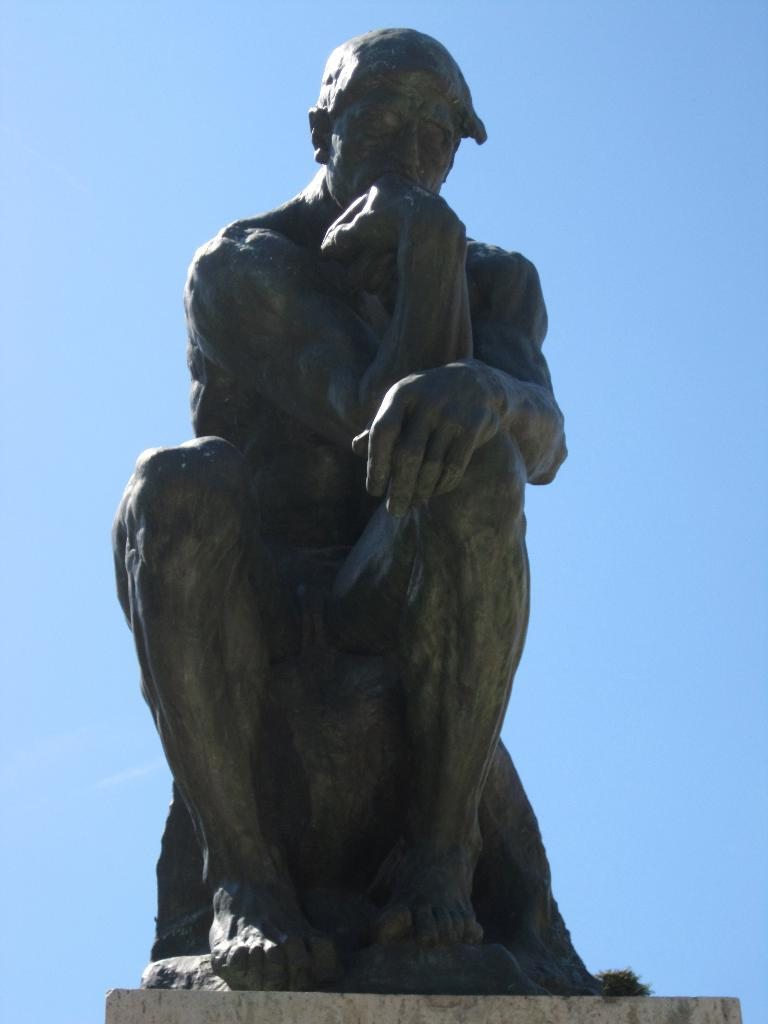What is the main subject of the image? There is a statue of a person in the image. Where is the statue located? The statue is placed on the ground. What can be seen in the background of the image? The sky is visible in the background of the image. What type of eggnog is being served at the statue's feet in the image? There is no eggnog present in the image; it features a statue of a person placed on the ground with the sky visible in the background. 